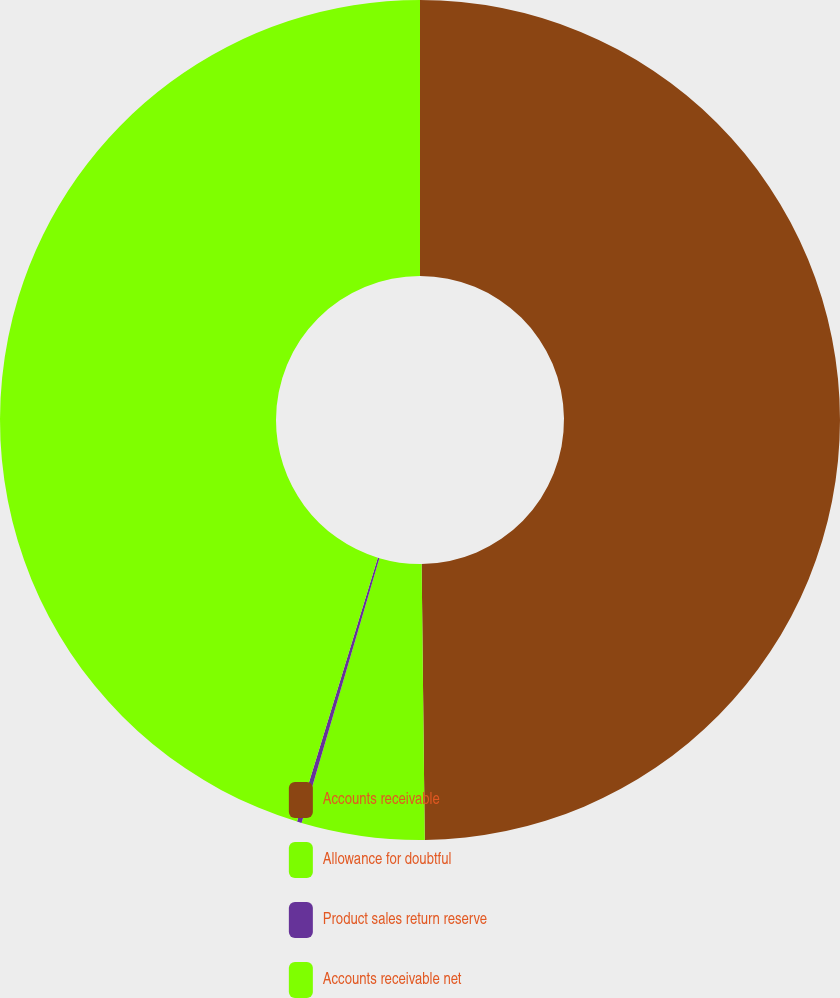Convert chart. <chart><loc_0><loc_0><loc_500><loc_500><pie_chart><fcel>Accounts receivable<fcel>Allowance for doubtful<fcel>Product sales return reserve<fcel>Accounts receivable net<nl><fcel>49.82%<fcel>4.73%<fcel>0.18%<fcel>45.27%<nl></chart> 